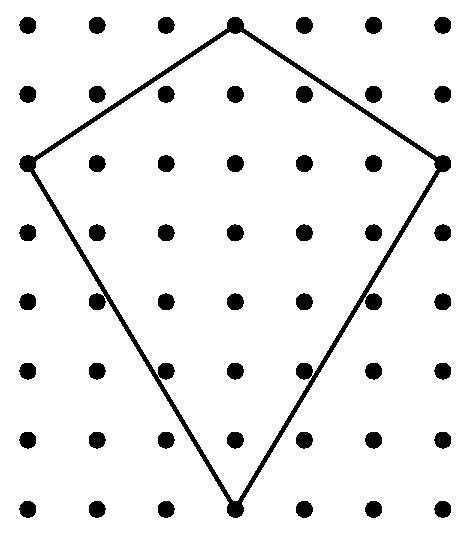How would the flight characteristics of the kite be affected if the bracing material was heavier or lighter? The weight of the bracing material can significantly affect the flight characteristics of the kite. Heavier bracing could make it more stable in strong winds but harder to lift off. Lighter material might make the kite more agile and easier to lift, but it could also make it less stable and more susceptible to damage or being overpowered by strong winds. 